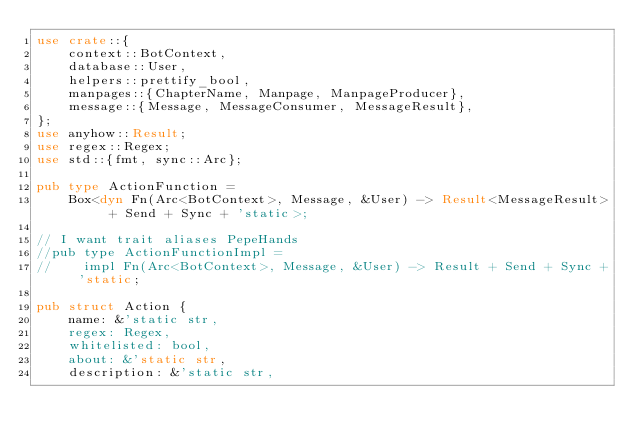<code> <loc_0><loc_0><loc_500><loc_500><_Rust_>use crate::{
    context::BotContext,
    database::User,
    helpers::prettify_bool,
    manpages::{ChapterName, Manpage, ManpageProducer},
    message::{Message, MessageConsumer, MessageResult},
};
use anyhow::Result;
use regex::Regex;
use std::{fmt, sync::Arc};

pub type ActionFunction =
    Box<dyn Fn(Arc<BotContext>, Message, &User) -> Result<MessageResult> + Send + Sync + 'static>;

// I want trait aliases PepeHands
//pub type ActionFunctionImpl =
//    impl Fn(Arc<BotContext>, Message, &User) -> Result + Send + Sync + 'static;

pub struct Action {
    name: &'static str,
    regex: Regex,
    whitelisted: bool,
    about: &'static str,
    description: &'static str,</code> 